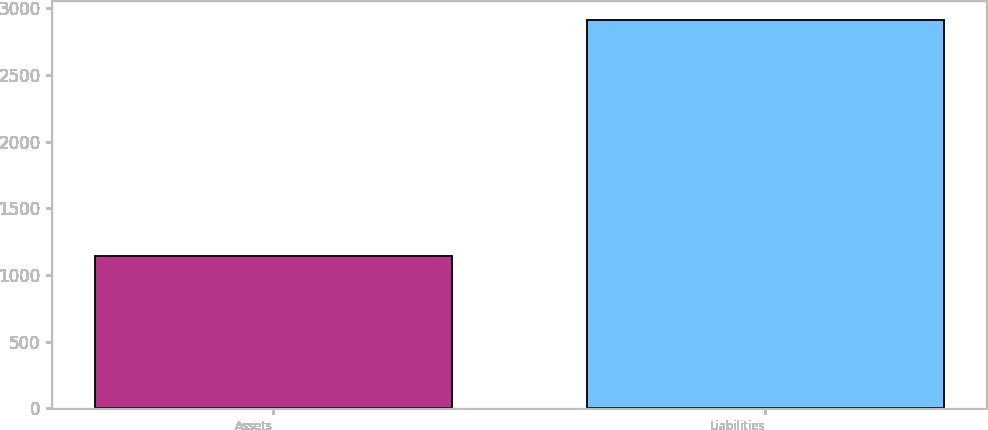Convert chart to OTSL. <chart><loc_0><loc_0><loc_500><loc_500><bar_chart><fcel>Assets<fcel>Liabilities<nl><fcel>1139<fcel>2910<nl></chart> 